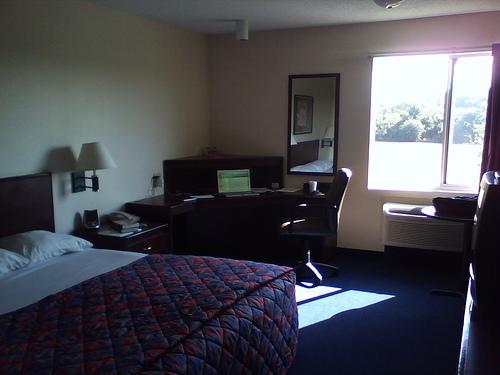Which side of the bed is the lamp?
Answer briefly. Right. What is in the corner?
Short answer required. Desk. What type of room is this?
Keep it brief. Bedroom. How many beds are in the room?
Give a very brief answer. 1. Does the room appear to be clean?
Concise answer only. Yes. 